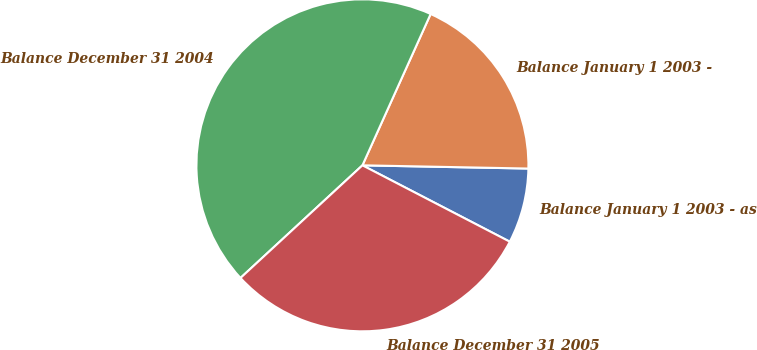Convert chart to OTSL. <chart><loc_0><loc_0><loc_500><loc_500><pie_chart><fcel>Balance January 1 2003 - as<fcel>Balance January 1 2003 -<fcel>Balance December 31 2004<fcel>Balance December 31 2005<nl><fcel>7.3%<fcel>18.57%<fcel>43.61%<fcel>30.52%<nl></chart> 